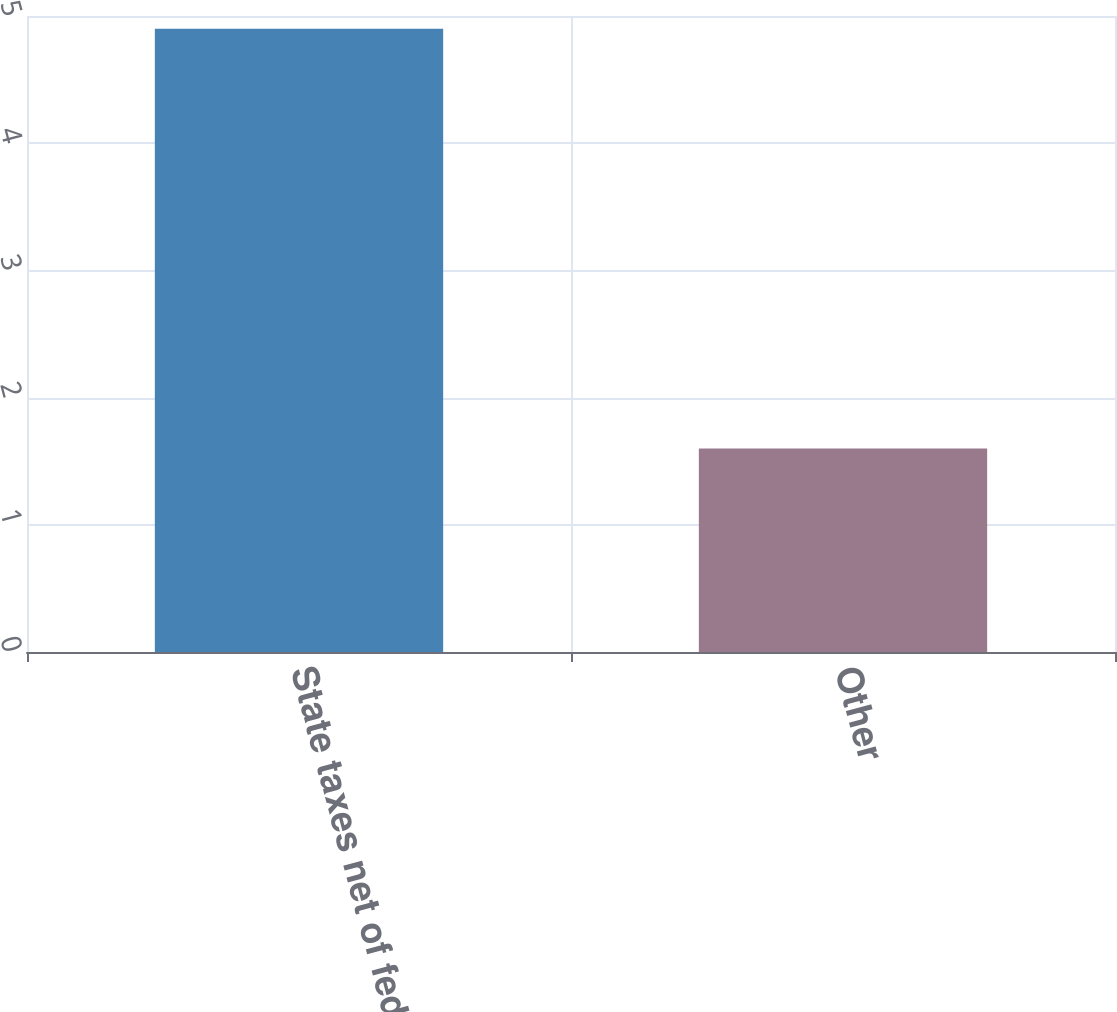<chart> <loc_0><loc_0><loc_500><loc_500><bar_chart><fcel>State taxes net of federal<fcel>Other<nl><fcel>4.9<fcel>1.6<nl></chart> 